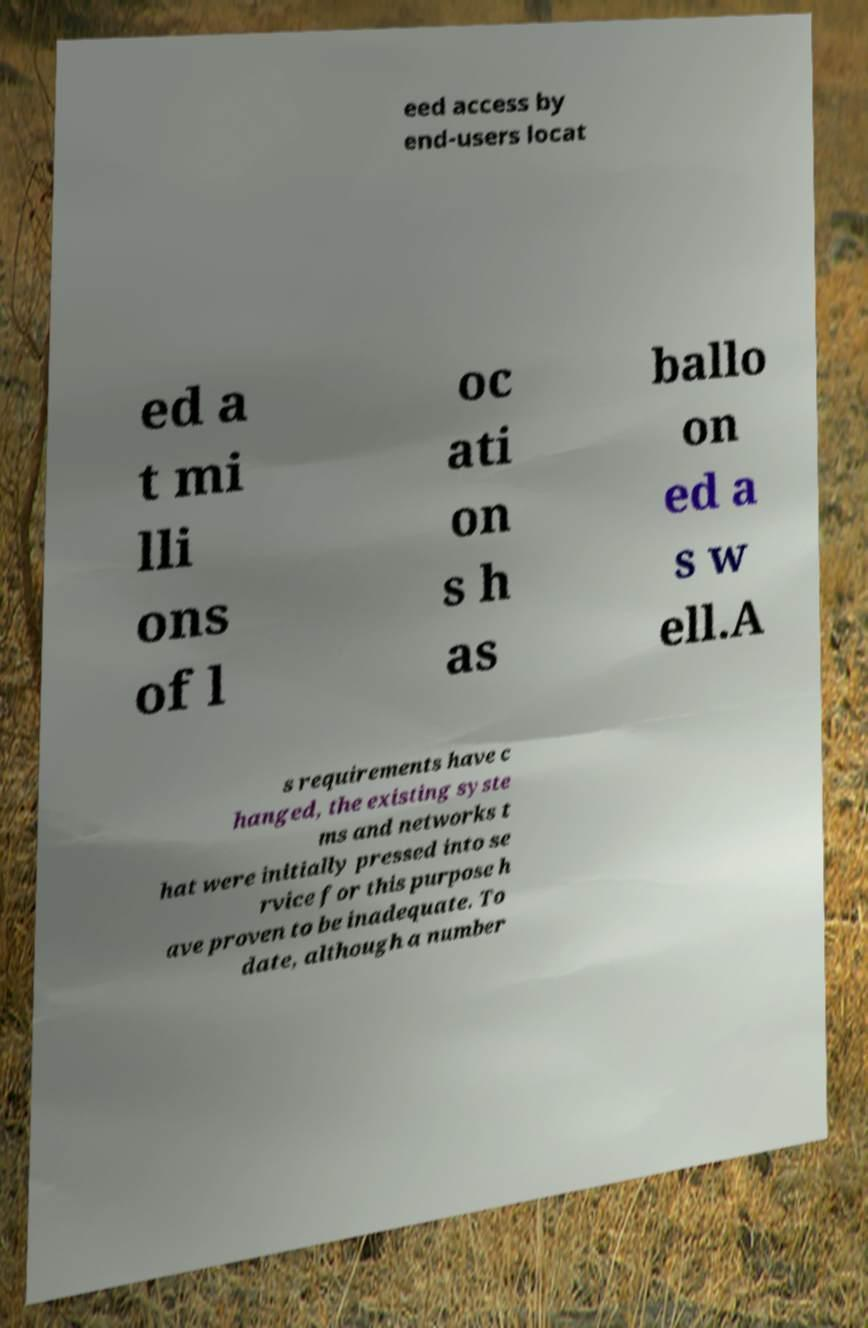Can you read and provide the text displayed in the image?This photo seems to have some interesting text. Can you extract and type it out for me? eed access by end-users locat ed a t mi lli ons of l oc ati on s h as ballo on ed a s w ell.A s requirements have c hanged, the existing syste ms and networks t hat were initially pressed into se rvice for this purpose h ave proven to be inadequate. To date, although a number 